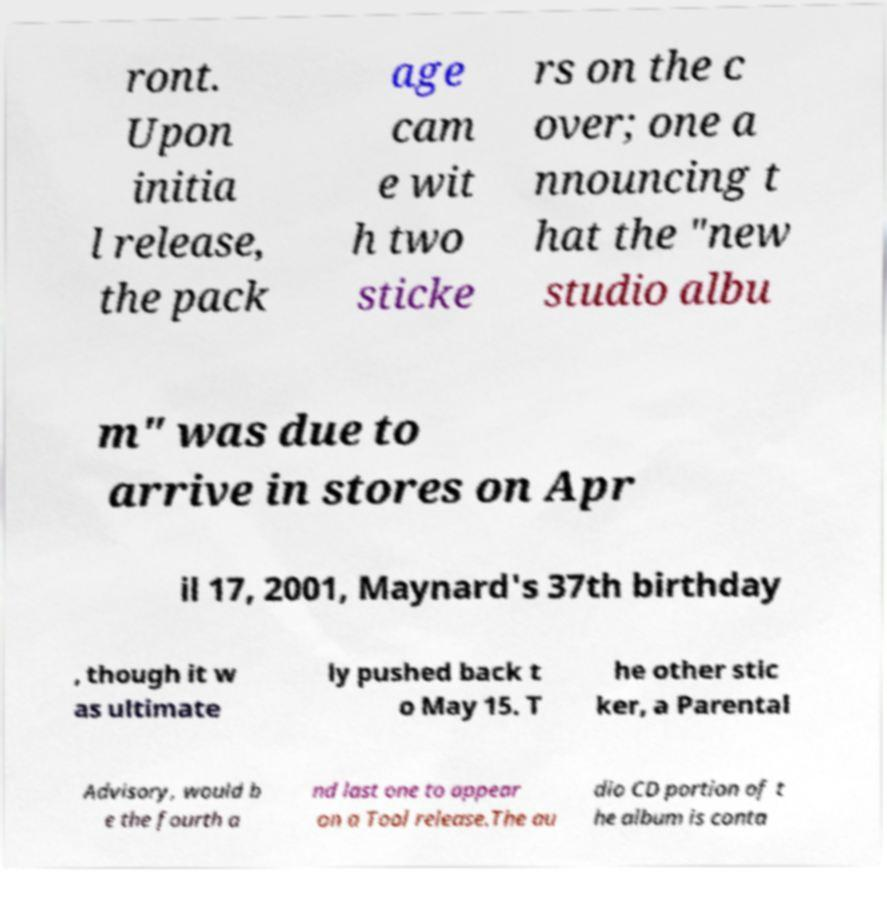For documentation purposes, I need the text within this image transcribed. Could you provide that? ront. Upon initia l release, the pack age cam e wit h two sticke rs on the c over; one a nnouncing t hat the "new studio albu m" was due to arrive in stores on Apr il 17, 2001, Maynard's 37th birthday , though it w as ultimate ly pushed back t o May 15. T he other stic ker, a Parental Advisory, would b e the fourth a nd last one to appear on a Tool release.The au dio CD portion of t he album is conta 